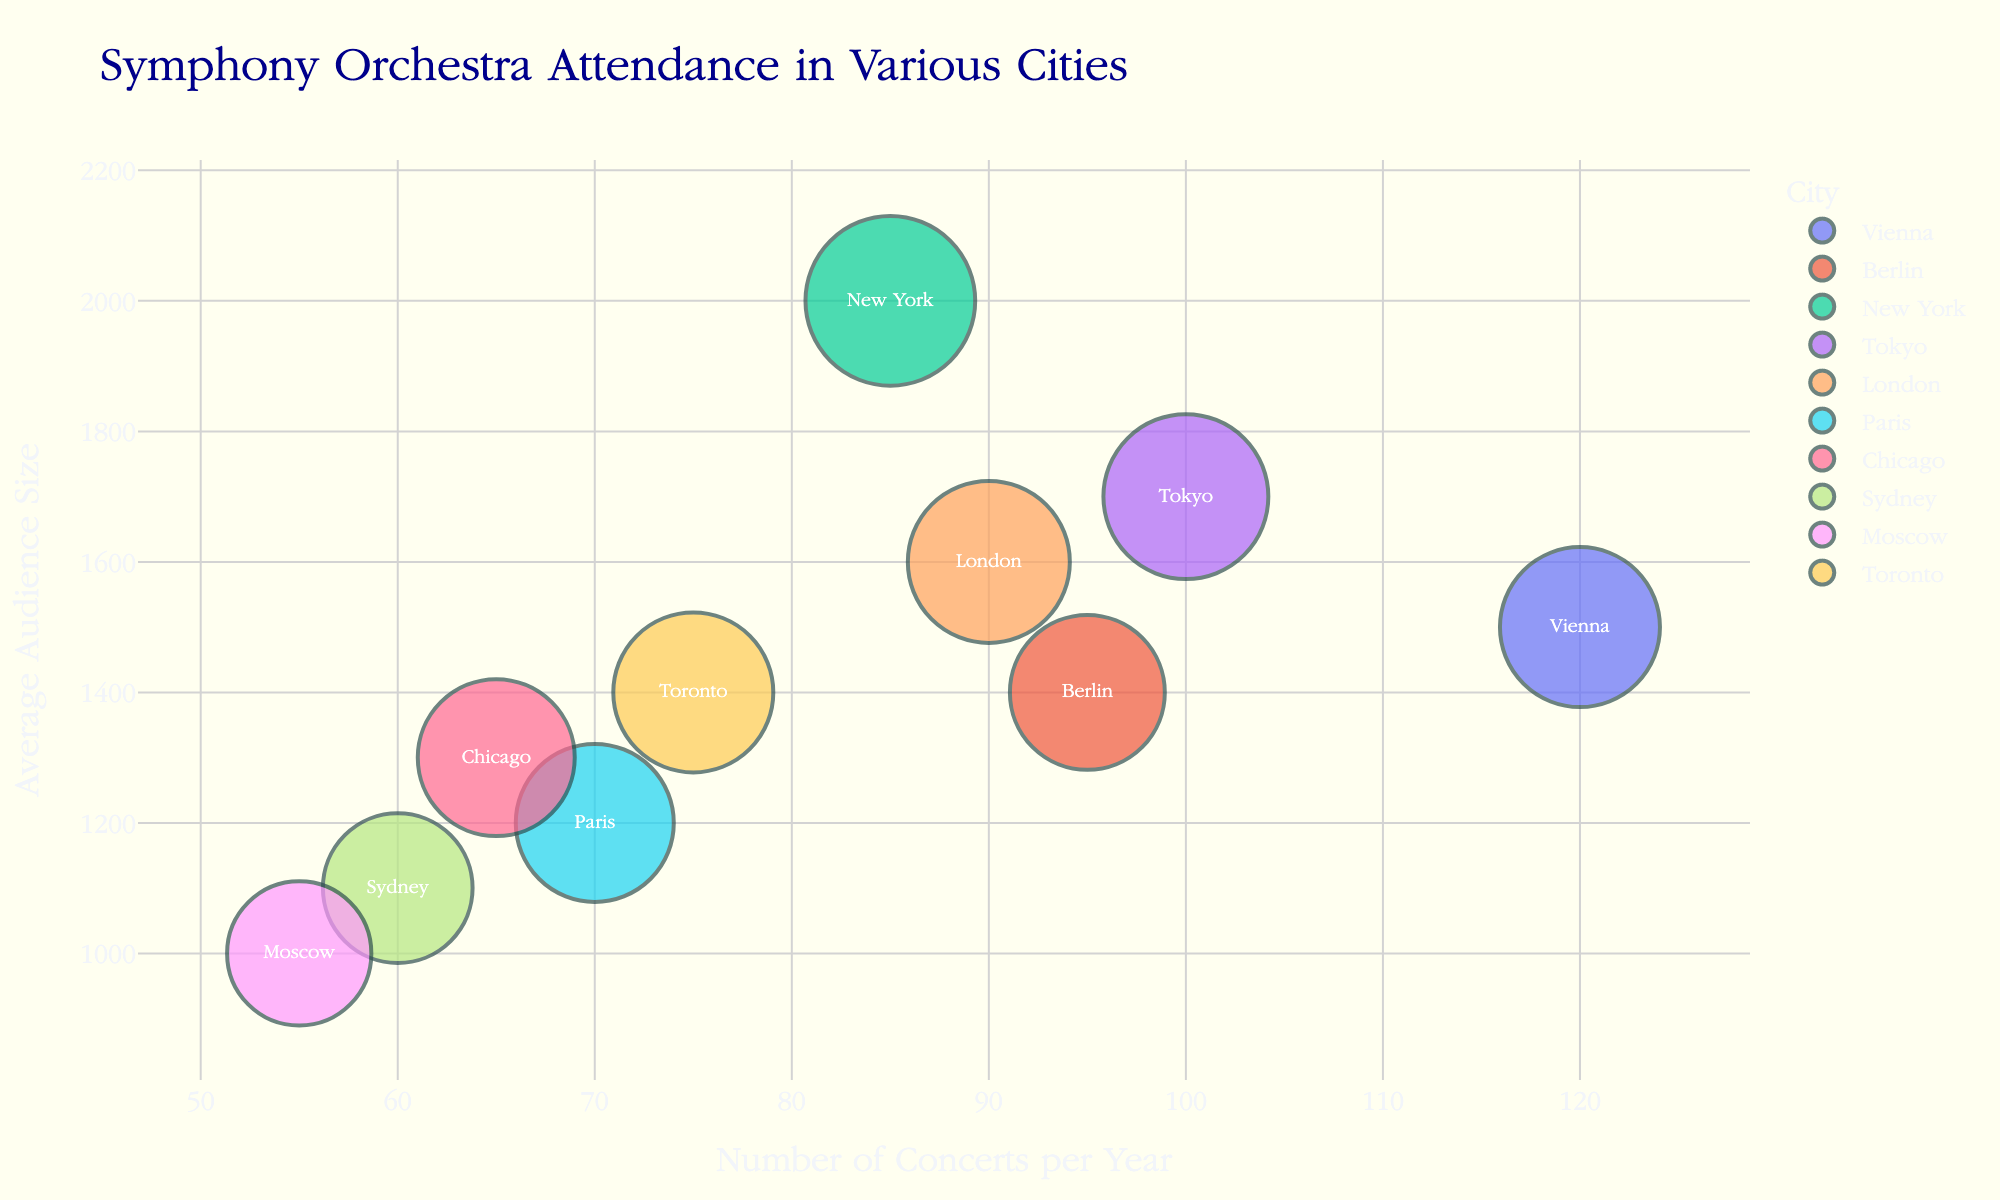What's the title of the chart? The title is prominently displayed at the top of the chart. It reads "Symphony Orchestra Attendance in Various Cities"
Answer: Symphony Orchestra Attendance in Various Cities Which city has the highest average audience size? By looking at the y-axis and identifying the bubble at the highest point, New York has the highest average audience size of 2000.
Answer: New York How many concerts does Vienna hold per year? Locate Vienna on the x-axis and read the corresponding value. Vienna holds 120 concerts per year.
Answer: 120 Which city has the smallest bubble size, and what does it represent? The smallest bubble size represents the lowest ticket price. Look at all the bubbles and find the smallest one. The smallest bubble belongs to Moscow, with a ticket price of $65.
Answer: Moscow, $65 What's the combined number of concerts in London and Paris? Find the bubbles for London and Paris on the x-axis to determine their concert numbers. London has 90, and Paris has 70 concerts per year. Adding them together, 90 + 70 = 160 concerts.
Answer: 160 Which city has a higher average audience size, Tokyo or Berlin? Compare the y-axis positions of Tokyo and Berlin. Tokyo has an average audience size of 1700, while Berlin has 1400. Therefore, Tokyo's average audience size is higher.
Answer: Tokyo What is the average ticket price in the cities shown? Add all the ticket prices and divide by the number of cities. (80 + 75 + 90 + 85 + 82 + 78 + 77 + 70 + 65 + 80) / 10 = 78.2
Answer: $78.2 Between Sydney and Toronto, which city has more concerts and by how many? Compare Sydney and Toronto on the x-axis. Sydney has 60 concerts, while Toronto has 75 concerts. Thus, Toronto has 75 - 60 = 15 more concerts than Sydney.
Answer: Toronto by 15 What is the relationship between the number of concerts and the average audience size as seen in the chart? The relationship can be inferred by observing how the bubbles are distributed along the x and y-axes. There is no clear linear relationship as cities with fewer concerts (like New York) can have a larger audience size, whereas cities with more concerts (like Vienna) have a moderate audience size. The distribution seems varied.
Answer: There is no clear linear relationship Which cities have an average ticket price of $80? Identify the bubbles that correspond to $80 on the size legend. Vienna and Toronto each have an average ticket price of $80.
Answer: Vienna and Toronto 